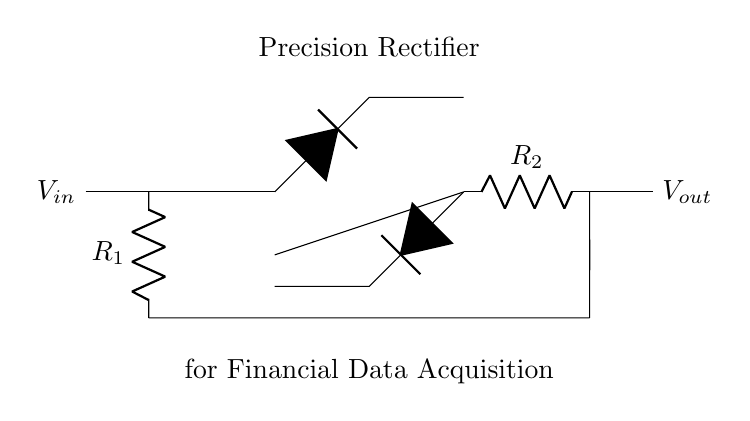What type of circuit is shown in the diagram? The circuit is a precision rectifier, which is evident from the labeling and the components used, particularly the op-amp and diodes arranged to rectify the input signal accurately.
Answer: precision rectifier What are the main components of this circuit? The main components include an operational amplifier, resistors, and diodes. The op-amp is in the center of the circuit, flanked by the resistors and diodes, which are also labeled.
Answer: operational amplifier, resistors, diodes What is the function of the diodes in this circuit? The diodes allow current to flow in one direction, enabling the rectification of the input signal. This is essential for converting the AC component of the input signal into a DC output, which is crucial for signal processing.
Answer: rectify the signal What is the role of R1 in the precision rectifier circuit? R1 serves as the input resistor, determining the gain of the op-amp stage and influencing the voltage levels seen by the diodes. Its value affects the precision and performance of the rectifier circuit.
Answer: input resistor How does the circuit ensure accurate signal processing? The precision rectifier utilizes an operational amplifier which provides high gain and minimizes the voltage drop across the diodes, ensuring that even small input signals are accurately rectified, thus offering precise processing essential for financial data acquisition systems.
Answer: operational amplifier's gain What is the expected output voltage behavior when the input voltage is negative? When the input voltage is negative, the op-amp will configure the diodes to prevent current from flowing, keeping the output voltage at zero. This ensures that only the positive half of the signal is rectified, preserving accuracy.
Answer: output voltage is zero What is the significance of using an operational amplifier in this rectifier? The operational amplifier provides high input impedance and low output impedance, which allows it to handle small input signals effectively while minimizing errors such as voltage drop across diodes, thus enhancing the accuracy of the rectification process.
Answer: enhances accuracy 